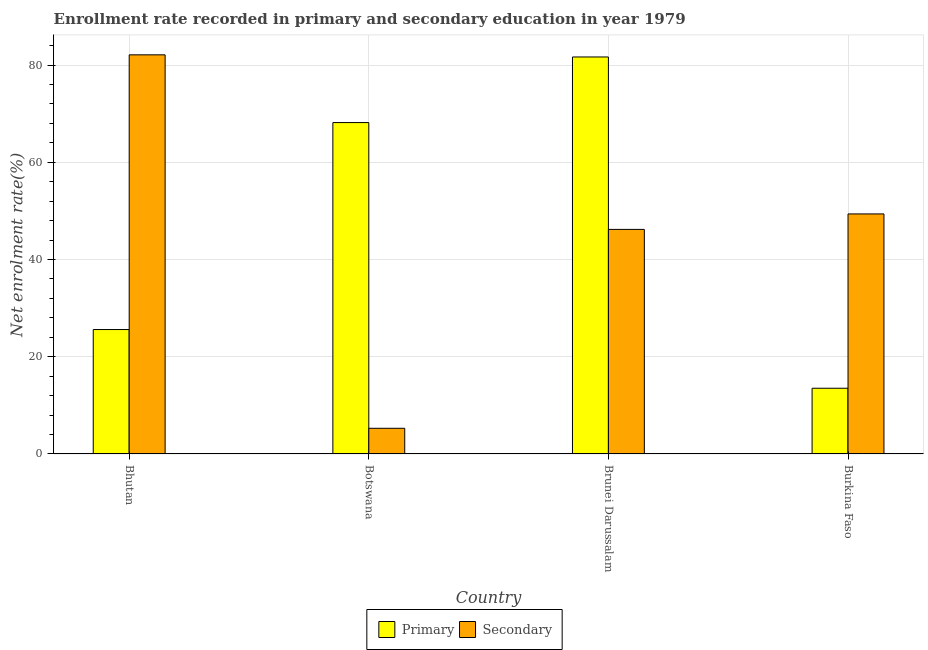Are the number of bars on each tick of the X-axis equal?
Your answer should be very brief. Yes. What is the label of the 3rd group of bars from the left?
Make the answer very short. Brunei Darussalam. What is the enrollment rate in secondary education in Bhutan?
Make the answer very short. 82.09. Across all countries, what is the maximum enrollment rate in secondary education?
Make the answer very short. 82.09. Across all countries, what is the minimum enrollment rate in primary education?
Make the answer very short. 13.52. In which country was the enrollment rate in secondary education maximum?
Your answer should be compact. Bhutan. In which country was the enrollment rate in primary education minimum?
Give a very brief answer. Burkina Faso. What is the total enrollment rate in secondary education in the graph?
Provide a succinct answer. 182.93. What is the difference between the enrollment rate in secondary education in Botswana and that in Brunei Darussalam?
Keep it short and to the point. -40.91. What is the difference between the enrollment rate in primary education in Burkina Faso and the enrollment rate in secondary education in Botswana?
Keep it short and to the point. 8.24. What is the average enrollment rate in primary education per country?
Offer a very short reply. 47.23. What is the difference between the enrollment rate in primary education and enrollment rate in secondary education in Bhutan?
Offer a terse response. -56.5. In how many countries, is the enrollment rate in primary education greater than 48 %?
Give a very brief answer. 2. What is the ratio of the enrollment rate in secondary education in Bhutan to that in Botswana?
Make the answer very short. 15.54. Is the enrollment rate in secondary education in Botswana less than that in Brunei Darussalam?
Ensure brevity in your answer.  Yes. Is the difference between the enrollment rate in primary education in Bhutan and Brunei Darussalam greater than the difference between the enrollment rate in secondary education in Bhutan and Brunei Darussalam?
Offer a very short reply. No. What is the difference between the highest and the second highest enrollment rate in secondary education?
Offer a terse response. 32.72. What is the difference between the highest and the lowest enrollment rate in secondary education?
Keep it short and to the point. 76.81. What does the 1st bar from the left in Botswana represents?
Provide a succinct answer. Primary. What does the 1st bar from the right in Burkina Faso represents?
Give a very brief answer. Secondary. How many bars are there?
Make the answer very short. 8. Are all the bars in the graph horizontal?
Provide a succinct answer. No. How many countries are there in the graph?
Your answer should be very brief. 4. Are the values on the major ticks of Y-axis written in scientific E-notation?
Provide a succinct answer. No. Does the graph contain any zero values?
Make the answer very short. No. Where does the legend appear in the graph?
Provide a short and direct response. Bottom center. How many legend labels are there?
Provide a succinct answer. 2. What is the title of the graph?
Your answer should be very brief. Enrollment rate recorded in primary and secondary education in year 1979. What is the label or title of the Y-axis?
Your answer should be compact. Net enrolment rate(%). What is the Net enrolment rate(%) of Primary in Bhutan?
Provide a succinct answer. 25.59. What is the Net enrolment rate(%) of Secondary in Bhutan?
Ensure brevity in your answer.  82.09. What is the Net enrolment rate(%) of Primary in Botswana?
Provide a short and direct response. 68.16. What is the Net enrolment rate(%) of Secondary in Botswana?
Keep it short and to the point. 5.28. What is the Net enrolment rate(%) of Primary in Brunei Darussalam?
Offer a very short reply. 81.65. What is the Net enrolment rate(%) in Secondary in Brunei Darussalam?
Give a very brief answer. 46.19. What is the Net enrolment rate(%) in Primary in Burkina Faso?
Make the answer very short. 13.52. What is the Net enrolment rate(%) of Secondary in Burkina Faso?
Offer a terse response. 49.37. Across all countries, what is the maximum Net enrolment rate(%) of Primary?
Your answer should be compact. 81.65. Across all countries, what is the maximum Net enrolment rate(%) of Secondary?
Your answer should be very brief. 82.09. Across all countries, what is the minimum Net enrolment rate(%) in Primary?
Keep it short and to the point. 13.52. Across all countries, what is the minimum Net enrolment rate(%) of Secondary?
Give a very brief answer. 5.28. What is the total Net enrolment rate(%) of Primary in the graph?
Give a very brief answer. 188.93. What is the total Net enrolment rate(%) of Secondary in the graph?
Offer a very short reply. 182.93. What is the difference between the Net enrolment rate(%) in Primary in Bhutan and that in Botswana?
Give a very brief answer. -42.57. What is the difference between the Net enrolment rate(%) in Secondary in Bhutan and that in Botswana?
Your answer should be very brief. 76.81. What is the difference between the Net enrolment rate(%) in Primary in Bhutan and that in Brunei Darussalam?
Offer a terse response. -56.06. What is the difference between the Net enrolment rate(%) in Secondary in Bhutan and that in Brunei Darussalam?
Keep it short and to the point. 35.9. What is the difference between the Net enrolment rate(%) of Primary in Bhutan and that in Burkina Faso?
Your answer should be compact. 12.07. What is the difference between the Net enrolment rate(%) in Secondary in Bhutan and that in Burkina Faso?
Your answer should be compact. 32.72. What is the difference between the Net enrolment rate(%) in Primary in Botswana and that in Brunei Darussalam?
Your response must be concise. -13.49. What is the difference between the Net enrolment rate(%) in Secondary in Botswana and that in Brunei Darussalam?
Your response must be concise. -40.91. What is the difference between the Net enrolment rate(%) of Primary in Botswana and that in Burkina Faso?
Offer a very short reply. 54.64. What is the difference between the Net enrolment rate(%) in Secondary in Botswana and that in Burkina Faso?
Make the answer very short. -44.09. What is the difference between the Net enrolment rate(%) of Primary in Brunei Darussalam and that in Burkina Faso?
Make the answer very short. 68.13. What is the difference between the Net enrolment rate(%) of Secondary in Brunei Darussalam and that in Burkina Faso?
Offer a very short reply. -3.18. What is the difference between the Net enrolment rate(%) in Primary in Bhutan and the Net enrolment rate(%) in Secondary in Botswana?
Give a very brief answer. 20.31. What is the difference between the Net enrolment rate(%) of Primary in Bhutan and the Net enrolment rate(%) of Secondary in Brunei Darussalam?
Your answer should be very brief. -20.6. What is the difference between the Net enrolment rate(%) in Primary in Bhutan and the Net enrolment rate(%) in Secondary in Burkina Faso?
Provide a succinct answer. -23.78. What is the difference between the Net enrolment rate(%) in Primary in Botswana and the Net enrolment rate(%) in Secondary in Brunei Darussalam?
Offer a terse response. 21.97. What is the difference between the Net enrolment rate(%) of Primary in Botswana and the Net enrolment rate(%) of Secondary in Burkina Faso?
Keep it short and to the point. 18.79. What is the difference between the Net enrolment rate(%) of Primary in Brunei Darussalam and the Net enrolment rate(%) of Secondary in Burkina Faso?
Ensure brevity in your answer.  32.28. What is the average Net enrolment rate(%) of Primary per country?
Offer a very short reply. 47.23. What is the average Net enrolment rate(%) of Secondary per country?
Provide a succinct answer. 45.73. What is the difference between the Net enrolment rate(%) in Primary and Net enrolment rate(%) in Secondary in Bhutan?
Ensure brevity in your answer.  -56.5. What is the difference between the Net enrolment rate(%) in Primary and Net enrolment rate(%) in Secondary in Botswana?
Provide a succinct answer. 62.88. What is the difference between the Net enrolment rate(%) in Primary and Net enrolment rate(%) in Secondary in Brunei Darussalam?
Offer a very short reply. 35.46. What is the difference between the Net enrolment rate(%) in Primary and Net enrolment rate(%) in Secondary in Burkina Faso?
Provide a short and direct response. -35.85. What is the ratio of the Net enrolment rate(%) of Primary in Bhutan to that in Botswana?
Give a very brief answer. 0.38. What is the ratio of the Net enrolment rate(%) of Secondary in Bhutan to that in Botswana?
Your response must be concise. 15.54. What is the ratio of the Net enrolment rate(%) of Primary in Bhutan to that in Brunei Darussalam?
Give a very brief answer. 0.31. What is the ratio of the Net enrolment rate(%) of Secondary in Bhutan to that in Brunei Darussalam?
Offer a very short reply. 1.78. What is the ratio of the Net enrolment rate(%) of Primary in Bhutan to that in Burkina Faso?
Provide a succinct answer. 1.89. What is the ratio of the Net enrolment rate(%) of Secondary in Bhutan to that in Burkina Faso?
Ensure brevity in your answer.  1.66. What is the ratio of the Net enrolment rate(%) in Primary in Botswana to that in Brunei Darussalam?
Provide a succinct answer. 0.83. What is the ratio of the Net enrolment rate(%) in Secondary in Botswana to that in Brunei Darussalam?
Your response must be concise. 0.11. What is the ratio of the Net enrolment rate(%) of Primary in Botswana to that in Burkina Faso?
Make the answer very short. 5.04. What is the ratio of the Net enrolment rate(%) in Secondary in Botswana to that in Burkina Faso?
Your answer should be compact. 0.11. What is the ratio of the Net enrolment rate(%) of Primary in Brunei Darussalam to that in Burkina Faso?
Your answer should be compact. 6.04. What is the ratio of the Net enrolment rate(%) of Secondary in Brunei Darussalam to that in Burkina Faso?
Provide a short and direct response. 0.94. What is the difference between the highest and the second highest Net enrolment rate(%) in Primary?
Your response must be concise. 13.49. What is the difference between the highest and the second highest Net enrolment rate(%) of Secondary?
Your answer should be very brief. 32.72. What is the difference between the highest and the lowest Net enrolment rate(%) of Primary?
Provide a short and direct response. 68.13. What is the difference between the highest and the lowest Net enrolment rate(%) of Secondary?
Your response must be concise. 76.81. 